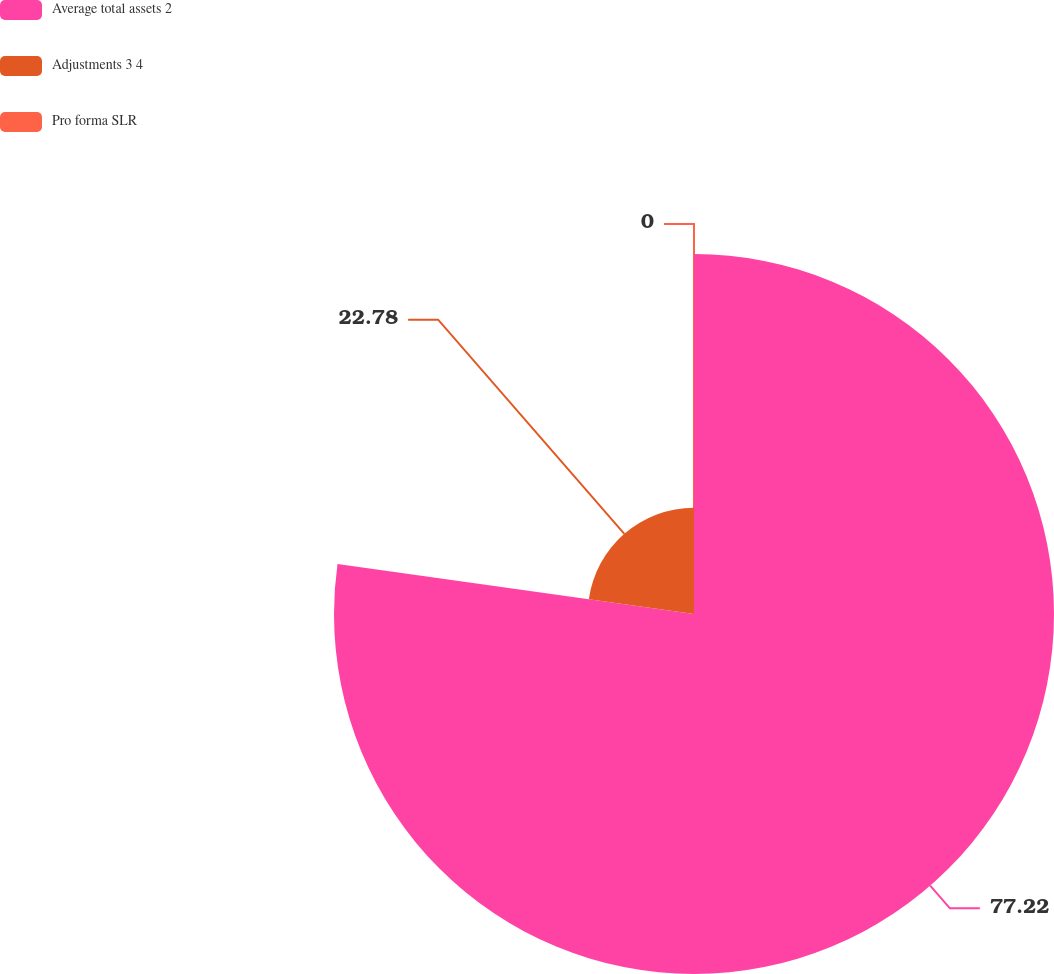Convert chart to OTSL. <chart><loc_0><loc_0><loc_500><loc_500><pie_chart><fcel>Average total assets 2<fcel>Adjustments 3 4<fcel>Pro forma SLR<nl><fcel>77.22%<fcel>22.78%<fcel>0.0%<nl></chart> 